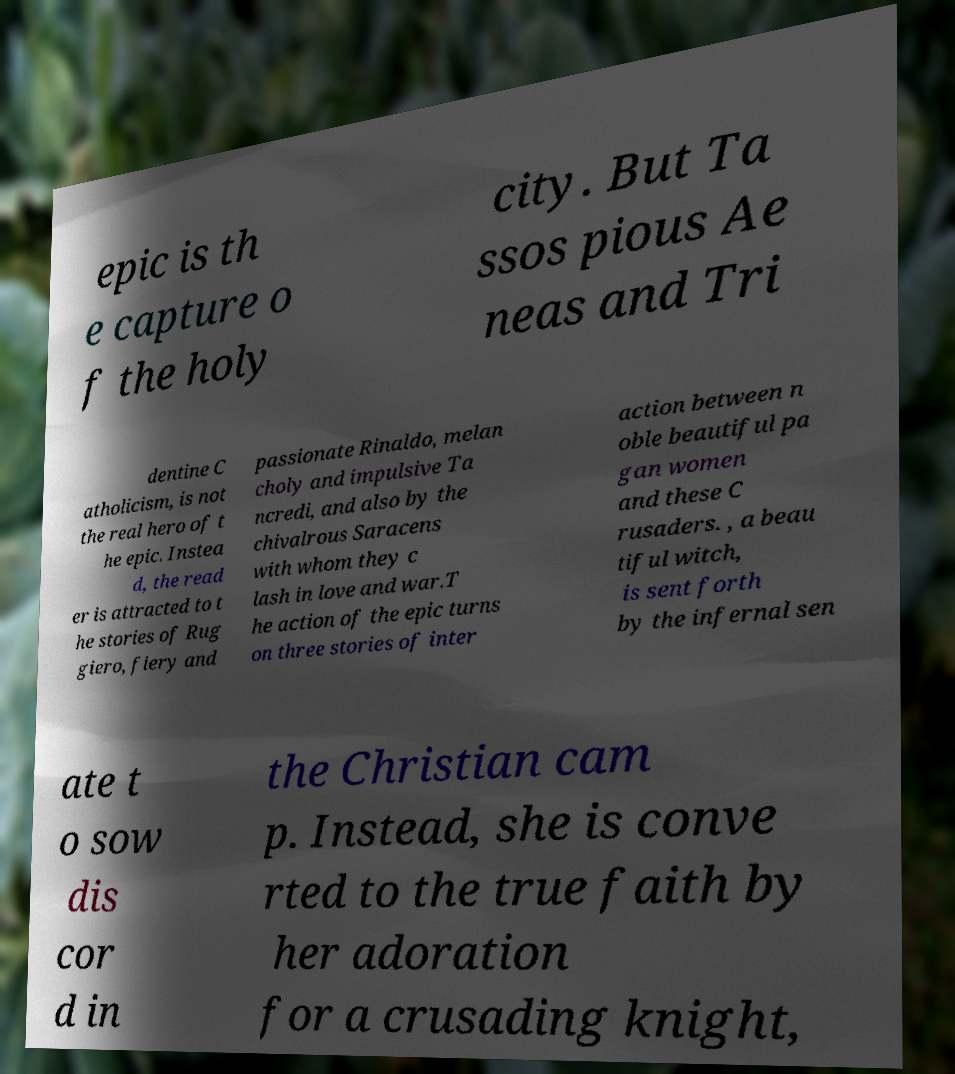Can you read and provide the text displayed in the image?This photo seems to have some interesting text. Can you extract and type it out for me? epic is th e capture o f the holy city. But Ta ssos pious Ae neas and Tri dentine C atholicism, is not the real hero of t he epic. Instea d, the read er is attracted to t he stories of Rug giero, fiery and passionate Rinaldo, melan choly and impulsive Ta ncredi, and also by the chivalrous Saracens with whom they c lash in love and war.T he action of the epic turns on three stories of inter action between n oble beautiful pa gan women and these C rusaders. , a beau tiful witch, is sent forth by the infernal sen ate t o sow dis cor d in the Christian cam p. Instead, she is conve rted to the true faith by her adoration for a crusading knight, 